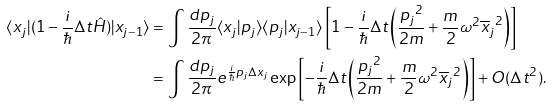<formula> <loc_0><loc_0><loc_500><loc_500>\langle x _ { j } | ( 1 - \frac { i } { \hbar } { \Delta } t \hat { H } ) | x _ { j - 1 } \rangle & = \int \frac { d p _ { j } } { 2 \pi } \langle x _ { j } | p _ { j } \rangle \langle p _ { j } | x _ { j - 1 } \rangle \left [ 1 - \frac { i } { \hbar } { \Delta } t \left ( \frac { { p _ { j } } ^ { 2 } } { 2 m } + \frac { m } { 2 } \omega ^ { 2 } { \overline { x } _ { j } } ^ { 2 } \right ) \right ] \\ & = \int \frac { d p _ { j } } { 2 \pi } e ^ { \frac { i } { \hbar } { p } _ { j } \Delta x _ { j } } \exp \left [ - \frac { i } { \hbar } { \Delta } t \left ( \frac { { p _ { j } } ^ { 2 } } { 2 m } + \frac { m } { 2 } \omega ^ { 2 } { \overline { x } _ { j } } ^ { 2 } \right ) \right ] + O ( \Delta t ^ { 2 } ) .</formula> 